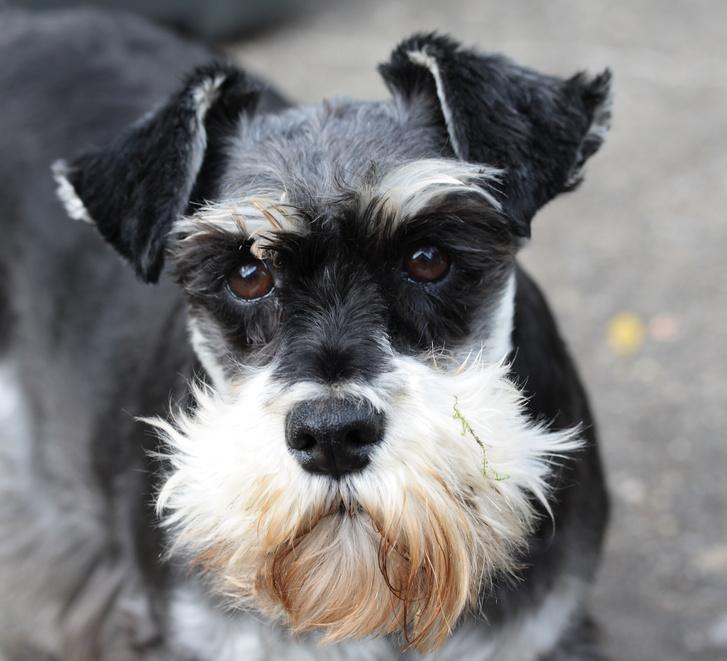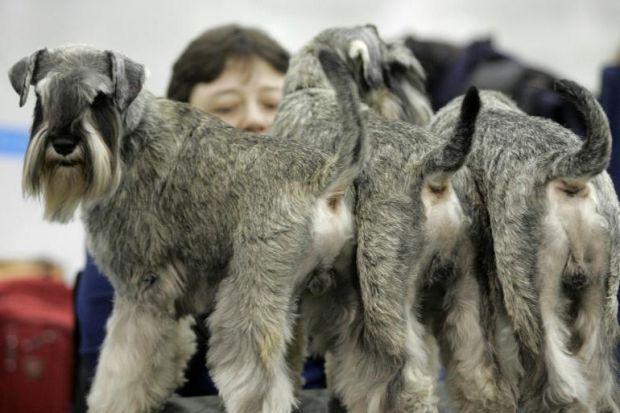The first image is the image on the left, the second image is the image on the right. Analyze the images presented: Is the assertion "a dog is posing with a taught loop around it's neck" valid? Answer yes or no. No. The first image is the image on the left, the second image is the image on the right. Given the left and right images, does the statement "There are three Schnauzers in one image, and one in the other." hold true? Answer yes or no. Yes. 